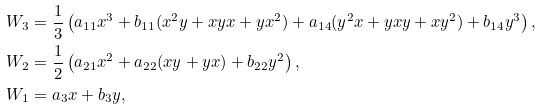Convert formula to latex. <formula><loc_0><loc_0><loc_500><loc_500>& W _ { 3 } = \frac { 1 } { 3 } \left ( a _ { 1 1 } x ^ { 3 } + b _ { 1 1 } ( x ^ { 2 } y + x y x + y x ^ { 2 } ) + a _ { 1 4 } ( y ^ { 2 } x + y x y + x y ^ { 2 } ) + b _ { 1 4 } y ^ { 3 } \right ) , \\ & W _ { 2 } = \frac { 1 } { 2 } \left ( a _ { 2 1 } x ^ { 2 } + a _ { 2 2 } ( x y + y x ) + b _ { 2 2 } y ^ { 2 } \right ) , \\ & W _ { 1 } = a _ { 3 } x + b _ { 3 } y ,</formula> 